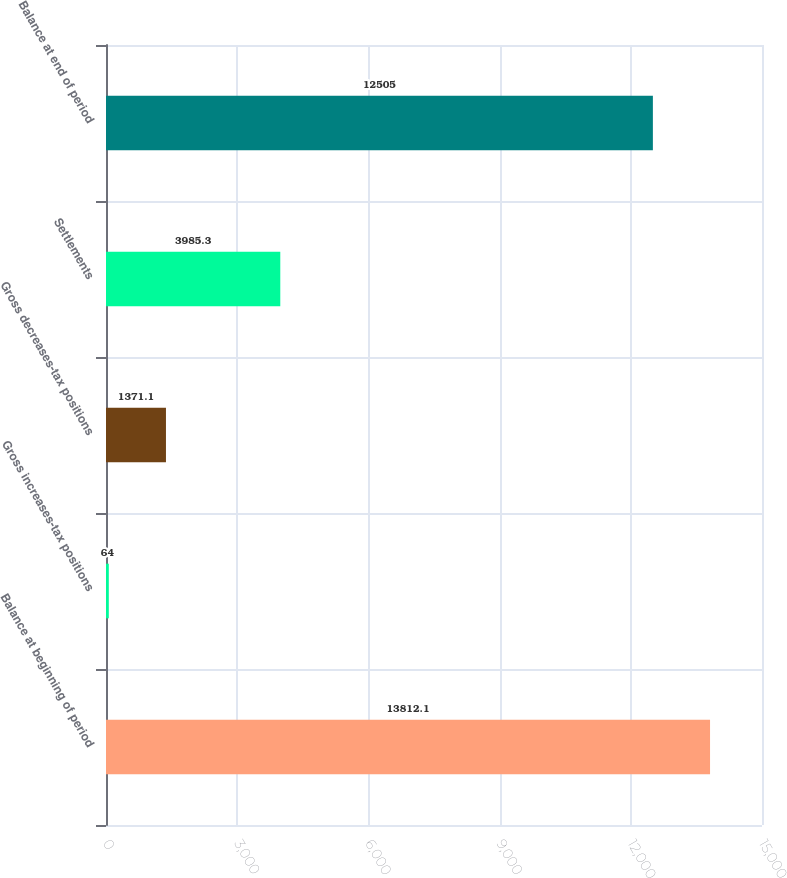Convert chart. <chart><loc_0><loc_0><loc_500><loc_500><bar_chart><fcel>Balance at beginning of period<fcel>Gross increases-tax positions<fcel>Gross decreases-tax positions<fcel>Settlements<fcel>Balance at end of period<nl><fcel>13812.1<fcel>64<fcel>1371.1<fcel>3985.3<fcel>12505<nl></chart> 